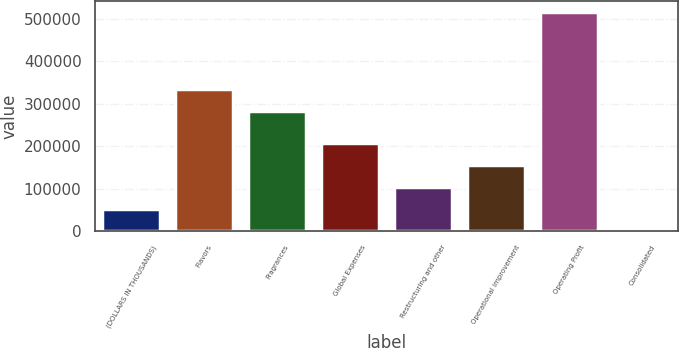Convert chart. <chart><loc_0><loc_0><loc_500><loc_500><bar_chart><fcel>(DOLLARS IN THOUSANDS)<fcel>Flavors<fcel>Fragrances<fcel>Global Expenses<fcel>Restructuring and other<fcel>Operational improvement<fcel>Operating Profit<fcel>Consolidated<nl><fcel>51649.7<fcel>335283<fcel>283651<fcel>206546<fcel>103282<fcel>154914<fcel>516339<fcel>17.5<nl></chart> 